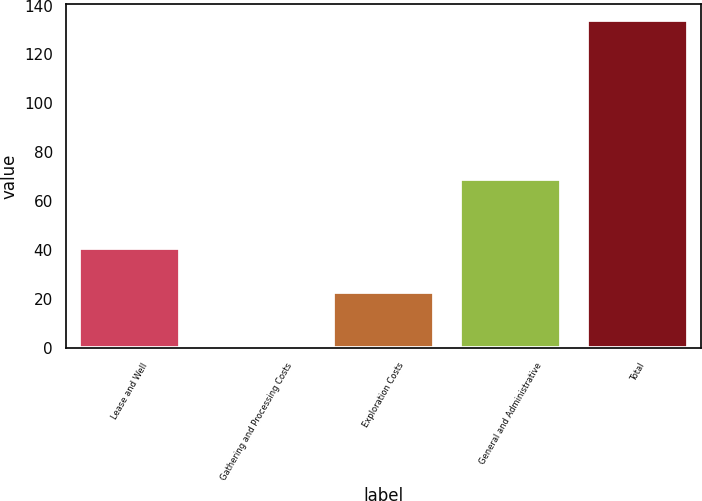Convert chart to OTSL. <chart><loc_0><loc_0><loc_500><loc_500><bar_chart><fcel>Lease and Well<fcel>Gathering and Processing Costs<fcel>Exploration Costs<fcel>General and Administrative<fcel>Total<nl><fcel>41<fcel>1<fcel>23<fcel>69<fcel>134<nl></chart> 